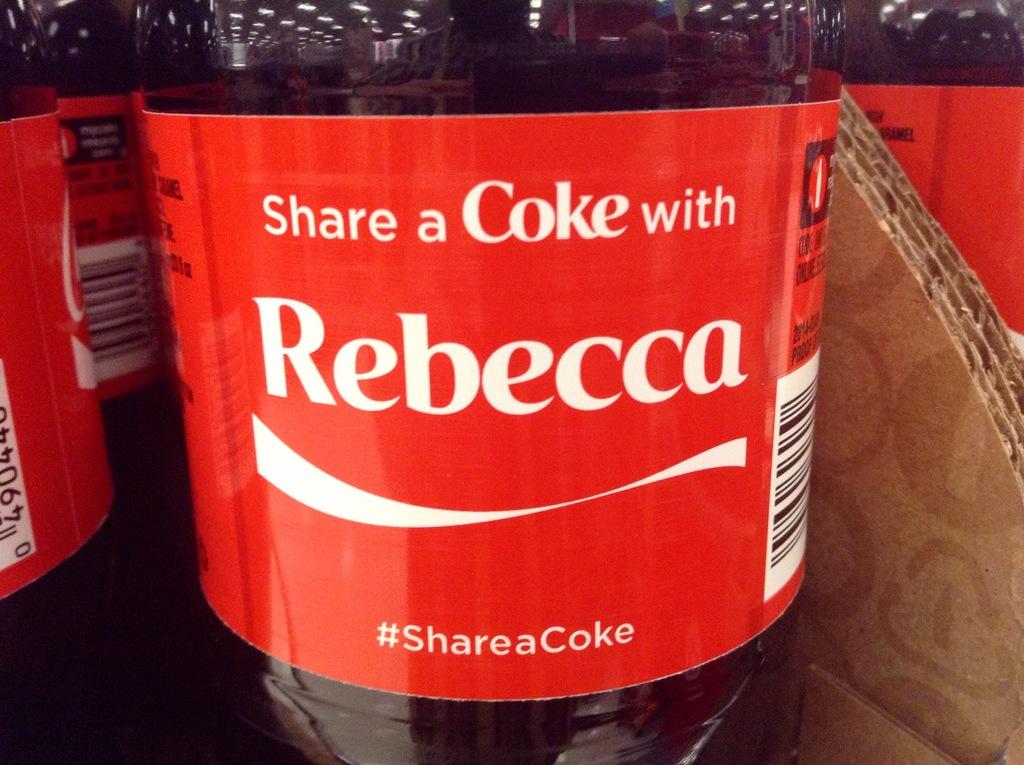What name is on this bottle?
Ensure brevity in your answer.  Rebecca. What is this bottle slogan?
Your answer should be very brief. Share a coke. 